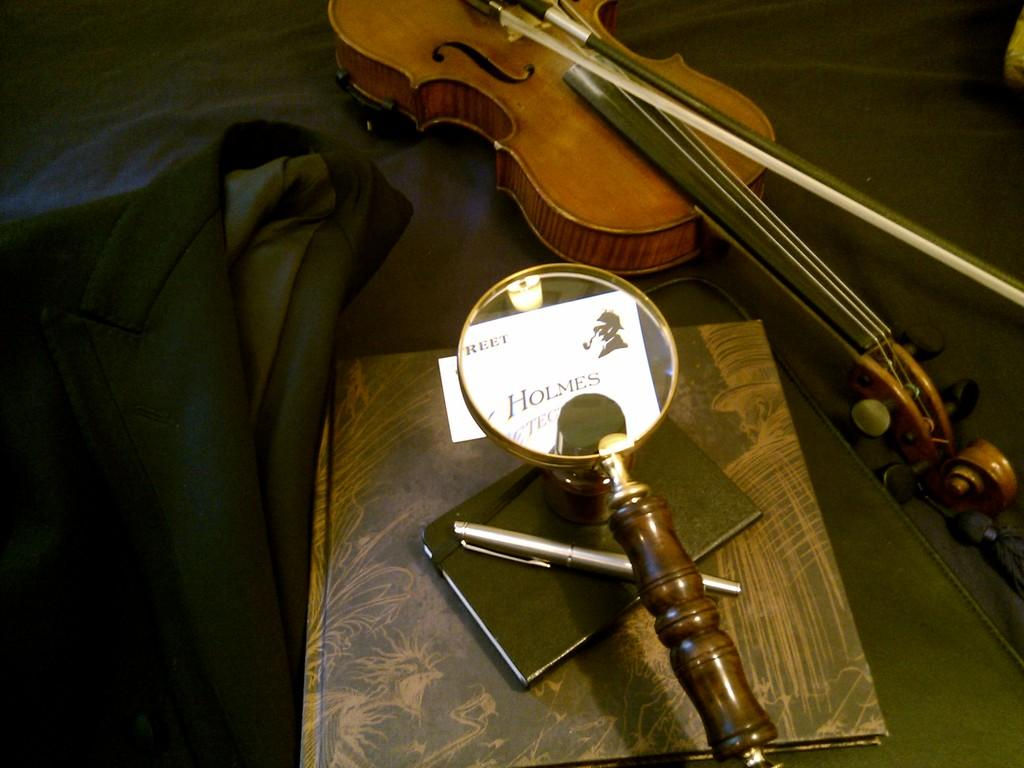What type of clothing item is visible in the image? There is a blazer in the image. What object related to photography can be seen in the image? There is a lens in the image. What writing instrument is present in the image? There is a pen in the image. What type of personal item is visible in the image? There is a diary in the image. What musical object is present in the image? There is a musical instrument in the image. What type of plot is being discussed in the image? There is no plot present in the image, as it features various objects such as a blazer, lens, pen, diary, and musical instrument. What event is taking place in the image? There is no specific event depicted in the image; it simply shows a collection of objects. 